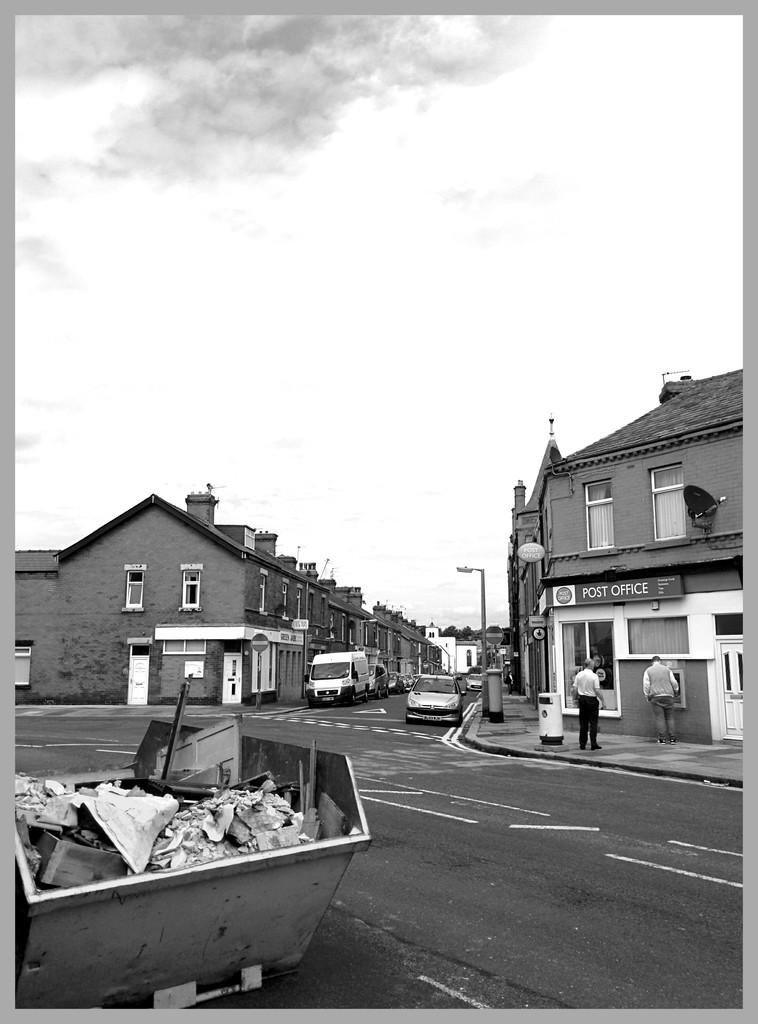What is the main object in the foreground of the image? There is a cart with garbage in the image. What can be seen in the background of the image? There are vehicles, people, buildings, and the sky visible in the background of the image. Can you describe the vehicles in the background? The vehicles in the background cannot be specifically described based on the provided facts. What type of environment is depicted in the image? The image shows a street or road with a cart, people, vehicles, buildings, and the sky. What type of cable is being used to control the brake of the cart in the image? There is no mention of a cable or brake in the image; it only shows a cart with garbage. 